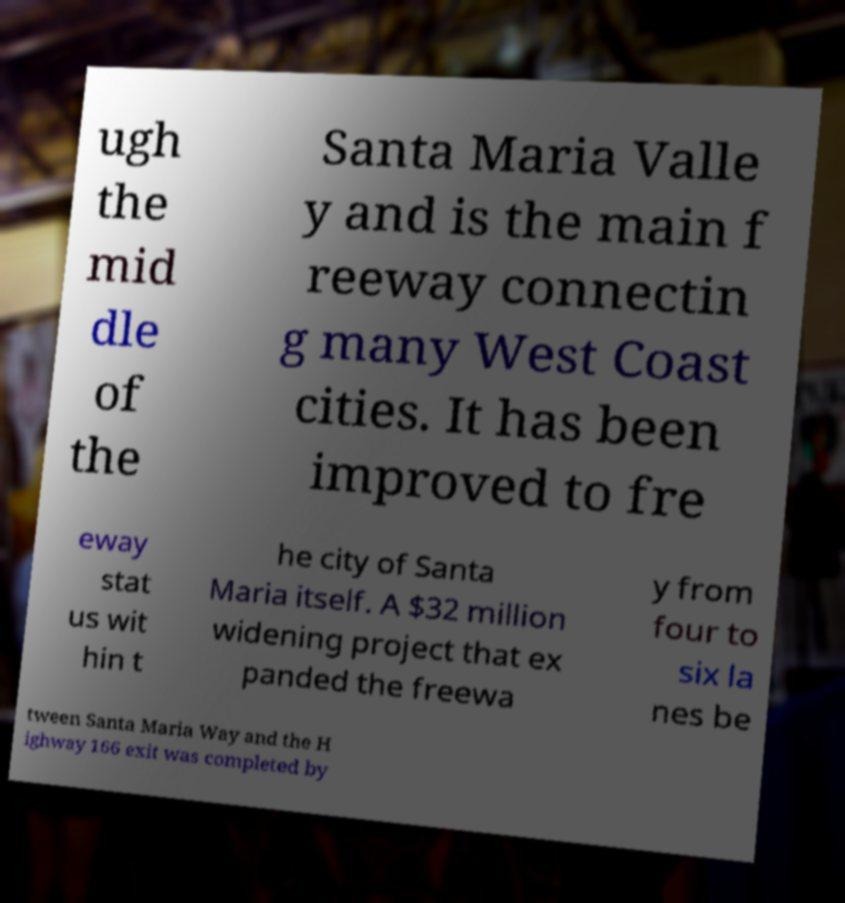Could you extract and type out the text from this image? ugh the mid dle of the Santa Maria Valle y and is the main f reeway connectin g many West Coast cities. It has been improved to fre eway stat us wit hin t he city of Santa Maria itself. A $32 million widening project that ex panded the freewa y from four to six la nes be tween Santa Maria Way and the H ighway 166 exit was completed by 